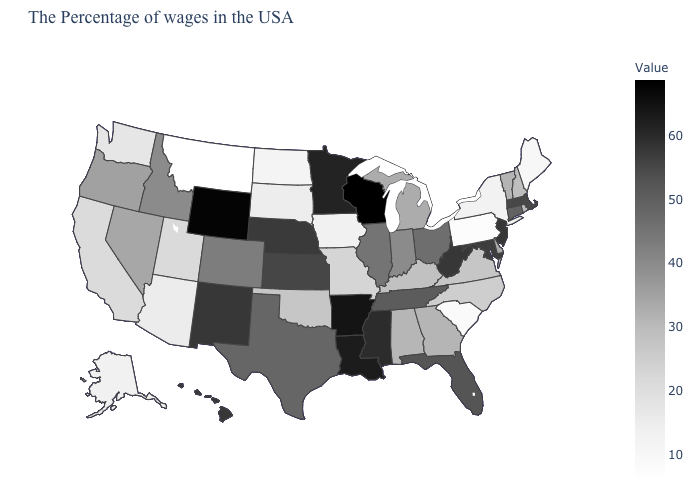Among the states that border Nevada , which have the lowest value?
Keep it brief. Arizona. Which states have the lowest value in the USA?
Quick response, please. Montana. Does the map have missing data?
Write a very short answer. No. Which states have the highest value in the USA?
Answer briefly. Wisconsin. Does Wisconsin have the highest value in the USA?
Write a very short answer. Yes. Does Wisconsin have the highest value in the USA?
Write a very short answer. Yes. Does the map have missing data?
Give a very brief answer. No. Which states have the lowest value in the USA?
Write a very short answer. Montana. 